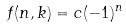<formula> <loc_0><loc_0><loc_500><loc_500>f ( n , k ) = c ( - 1 ) ^ { n }</formula> 